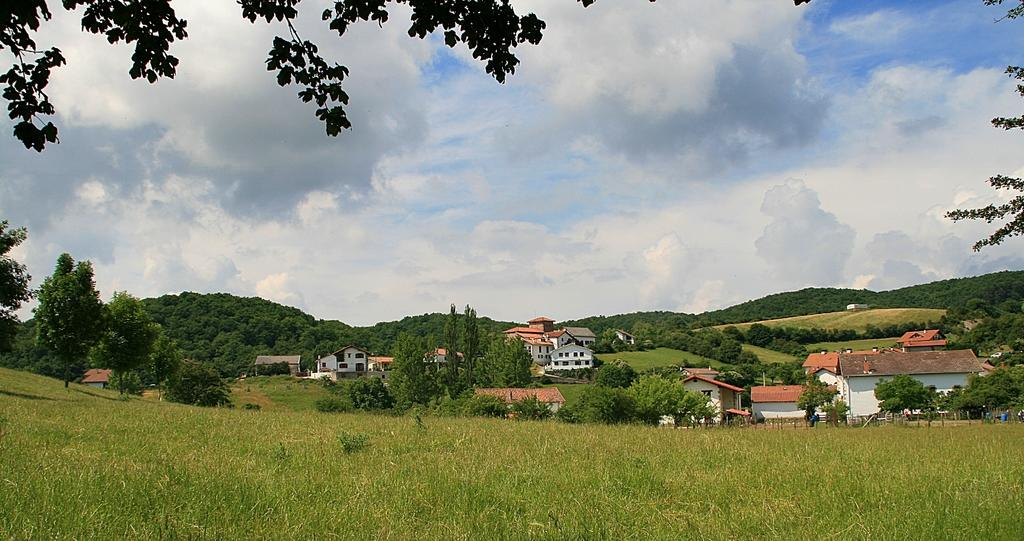What type of ground surface is visible in the image? There is grass on the ground in the image. What can be seen in the distance behind the grass? There are trees and buildings in the background of the image. What is the condition of the sky in the image? The sky is cloudy in the image. What type of joke is being told by the wire in the image? There is no wire present in the image, and therefore no joke can be attributed to it. 